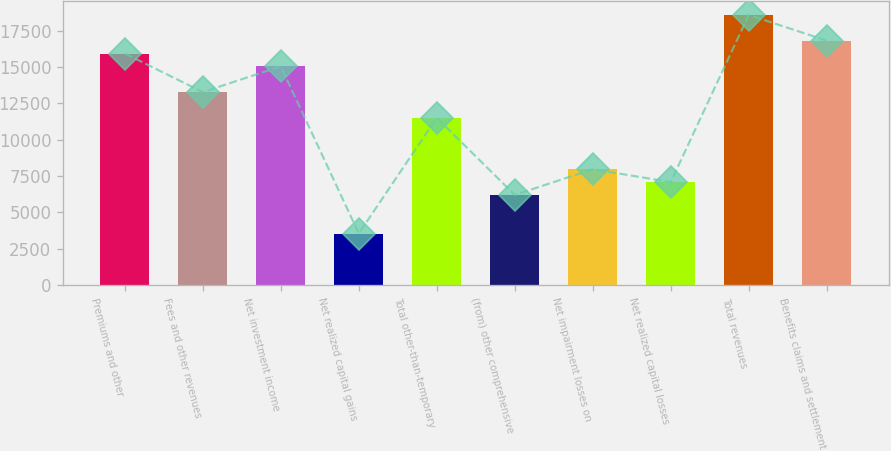<chart> <loc_0><loc_0><loc_500><loc_500><bar_chart><fcel>Premiums and other<fcel>Fees and other revenues<fcel>Net investment income<fcel>Net realized capital gains<fcel>Total other-than-temporary<fcel>(from) other comprehensive<fcel>Net impairment losses on<fcel>Net realized capital losses<fcel>Total revenues<fcel>Benefits claims and settlement<nl><fcel>15926.8<fcel>13272.6<fcel>15042<fcel>3540.81<fcel>11503.2<fcel>6194.94<fcel>7964.36<fcel>7079.65<fcel>18580.9<fcel>16811.5<nl></chart> 